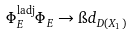<formula> <loc_0><loc_0><loc_500><loc_500>\Phi ^ { \text {ladj} } _ { E } \Phi _ { E } \rightarrow \i d _ { D ( X _ { 1 } ) }</formula> 